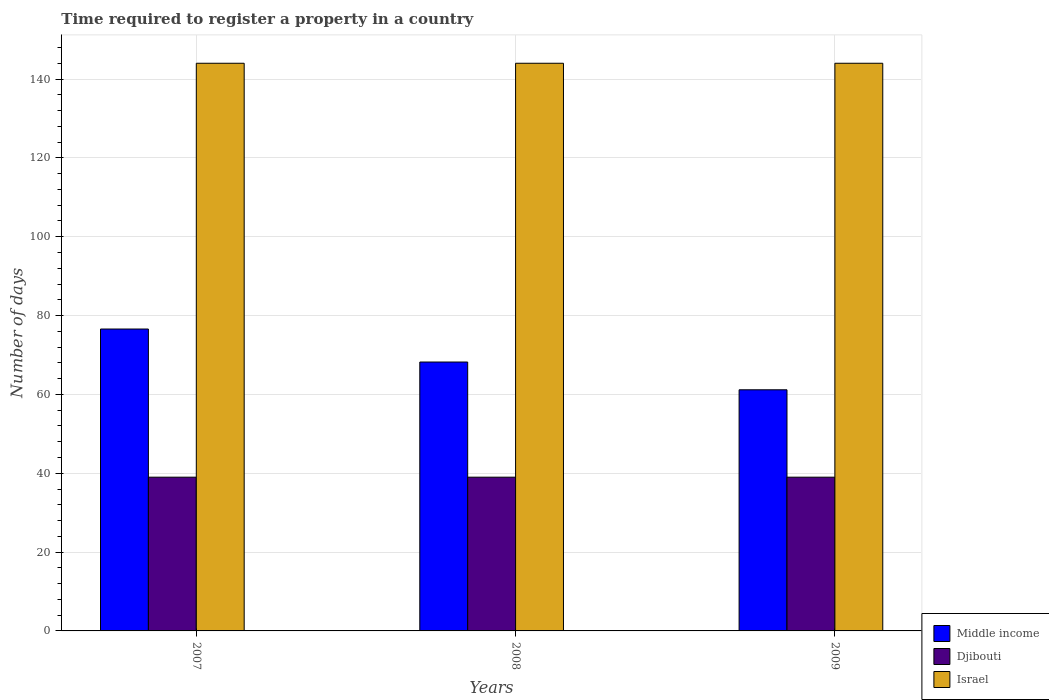How many different coloured bars are there?
Your response must be concise. 3. How many groups of bars are there?
Your answer should be very brief. 3. Are the number of bars per tick equal to the number of legend labels?
Give a very brief answer. Yes. Are the number of bars on each tick of the X-axis equal?
Provide a succinct answer. Yes. In how many cases, is the number of bars for a given year not equal to the number of legend labels?
Provide a short and direct response. 0. What is the number of days required to register a property in Middle income in 2008?
Your answer should be compact. 68.21. Across all years, what is the maximum number of days required to register a property in Israel?
Keep it short and to the point. 144. Across all years, what is the minimum number of days required to register a property in Israel?
Provide a succinct answer. 144. In which year was the number of days required to register a property in Israel maximum?
Your answer should be very brief. 2007. What is the total number of days required to register a property in Israel in the graph?
Your answer should be compact. 432. What is the difference between the number of days required to register a property in Israel in 2007 and that in 2009?
Your response must be concise. 0. What is the difference between the number of days required to register a property in Israel in 2008 and the number of days required to register a property in Djibouti in 2009?
Offer a terse response. 105. What is the average number of days required to register a property in Israel per year?
Offer a very short reply. 144. In the year 2009, what is the difference between the number of days required to register a property in Israel and number of days required to register a property in Djibouti?
Offer a terse response. 105. In how many years, is the number of days required to register a property in Djibouti greater than 140 days?
Your answer should be very brief. 0. Is the number of days required to register a property in Middle income in 2007 less than that in 2009?
Provide a short and direct response. No. What is the difference between the highest and the lowest number of days required to register a property in Middle income?
Your answer should be very brief. 15.41. Is it the case that in every year, the sum of the number of days required to register a property in Middle income and number of days required to register a property in Djibouti is greater than the number of days required to register a property in Israel?
Provide a short and direct response. No. How many bars are there?
Your answer should be very brief. 9. Are all the bars in the graph horizontal?
Provide a short and direct response. No. What is the difference between two consecutive major ticks on the Y-axis?
Offer a very short reply. 20. How many legend labels are there?
Your response must be concise. 3. How are the legend labels stacked?
Offer a terse response. Vertical. What is the title of the graph?
Offer a terse response. Time required to register a property in a country. Does "Bhutan" appear as one of the legend labels in the graph?
Keep it short and to the point. No. What is the label or title of the Y-axis?
Your answer should be very brief. Number of days. What is the Number of days in Middle income in 2007?
Give a very brief answer. 76.58. What is the Number of days of Djibouti in 2007?
Provide a short and direct response. 39. What is the Number of days in Israel in 2007?
Provide a short and direct response. 144. What is the Number of days in Middle income in 2008?
Your response must be concise. 68.21. What is the Number of days of Djibouti in 2008?
Your answer should be very brief. 39. What is the Number of days of Israel in 2008?
Your response must be concise. 144. What is the Number of days in Middle income in 2009?
Give a very brief answer. 61.17. What is the Number of days in Djibouti in 2009?
Offer a very short reply. 39. What is the Number of days of Israel in 2009?
Provide a succinct answer. 144. Across all years, what is the maximum Number of days in Middle income?
Provide a succinct answer. 76.58. Across all years, what is the maximum Number of days in Djibouti?
Give a very brief answer. 39. Across all years, what is the maximum Number of days of Israel?
Provide a succinct answer. 144. Across all years, what is the minimum Number of days in Middle income?
Offer a terse response. 61.17. Across all years, what is the minimum Number of days of Djibouti?
Give a very brief answer. 39. Across all years, what is the minimum Number of days of Israel?
Ensure brevity in your answer.  144. What is the total Number of days of Middle income in the graph?
Provide a short and direct response. 205.96. What is the total Number of days in Djibouti in the graph?
Give a very brief answer. 117. What is the total Number of days in Israel in the graph?
Keep it short and to the point. 432. What is the difference between the Number of days in Middle income in 2007 and that in 2008?
Your response must be concise. 8.37. What is the difference between the Number of days in Israel in 2007 and that in 2008?
Provide a short and direct response. 0. What is the difference between the Number of days in Middle income in 2007 and that in 2009?
Make the answer very short. 15.41. What is the difference between the Number of days of Israel in 2007 and that in 2009?
Your response must be concise. 0. What is the difference between the Number of days in Middle income in 2008 and that in 2009?
Your answer should be compact. 7.04. What is the difference between the Number of days in Djibouti in 2008 and that in 2009?
Provide a short and direct response. 0. What is the difference between the Number of days of Middle income in 2007 and the Number of days of Djibouti in 2008?
Your response must be concise. 37.58. What is the difference between the Number of days of Middle income in 2007 and the Number of days of Israel in 2008?
Provide a succinct answer. -67.42. What is the difference between the Number of days in Djibouti in 2007 and the Number of days in Israel in 2008?
Provide a succinct answer. -105. What is the difference between the Number of days in Middle income in 2007 and the Number of days in Djibouti in 2009?
Provide a short and direct response. 37.58. What is the difference between the Number of days in Middle income in 2007 and the Number of days in Israel in 2009?
Ensure brevity in your answer.  -67.42. What is the difference between the Number of days in Djibouti in 2007 and the Number of days in Israel in 2009?
Provide a short and direct response. -105. What is the difference between the Number of days in Middle income in 2008 and the Number of days in Djibouti in 2009?
Offer a very short reply. 29.21. What is the difference between the Number of days of Middle income in 2008 and the Number of days of Israel in 2009?
Ensure brevity in your answer.  -75.79. What is the difference between the Number of days in Djibouti in 2008 and the Number of days in Israel in 2009?
Offer a very short reply. -105. What is the average Number of days in Middle income per year?
Make the answer very short. 68.65. What is the average Number of days in Djibouti per year?
Keep it short and to the point. 39. What is the average Number of days in Israel per year?
Make the answer very short. 144. In the year 2007, what is the difference between the Number of days in Middle income and Number of days in Djibouti?
Your answer should be compact. 37.58. In the year 2007, what is the difference between the Number of days of Middle income and Number of days of Israel?
Your answer should be compact. -67.42. In the year 2007, what is the difference between the Number of days of Djibouti and Number of days of Israel?
Make the answer very short. -105. In the year 2008, what is the difference between the Number of days in Middle income and Number of days in Djibouti?
Your answer should be very brief. 29.21. In the year 2008, what is the difference between the Number of days of Middle income and Number of days of Israel?
Keep it short and to the point. -75.79. In the year 2008, what is the difference between the Number of days of Djibouti and Number of days of Israel?
Offer a very short reply. -105. In the year 2009, what is the difference between the Number of days of Middle income and Number of days of Djibouti?
Provide a short and direct response. 22.17. In the year 2009, what is the difference between the Number of days of Middle income and Number of days of Israel?
Keep it short and to the point. -82.83. In the year 2009, what is the difference between the Number of days of Djibouti and Number of days of Israel?
Offer a very short reply. -105. What is the ratio of the Number of days of Middle income in 2007 to that in 2008?
Give a very brief answer. 1.12. What is the ratio of the Number of days of Israel in 2007 to that in 2008?
Offer a terse response. 1. What is the ratio of the Number of days in Middle income in 2007 to that in 2009?
Provide a succinct answer. 1.25. What is the ratio of the Number of days in Djibouti in 2007 to that in 2009?
Keep it short and to the point. 1. What is the ratio of the Number of days in Middle income in 2008 to that in 2009?
Your response must be concise. 1.12. What is the difference between the highest and the second highest Number of days of Middle income?
Ensure brevity in your answer.  8.37. What is the difference between the highest and the second highest Number of days in Israel?
Your answer should be very brief. 0. What is the difference between the highest and the lowest Number of days in Middle income?
Ensure brevity in your answer.  15.41. What is the difference between the highest and the lowest Number of days of Djibouti?
Make the answer very short. 0. 